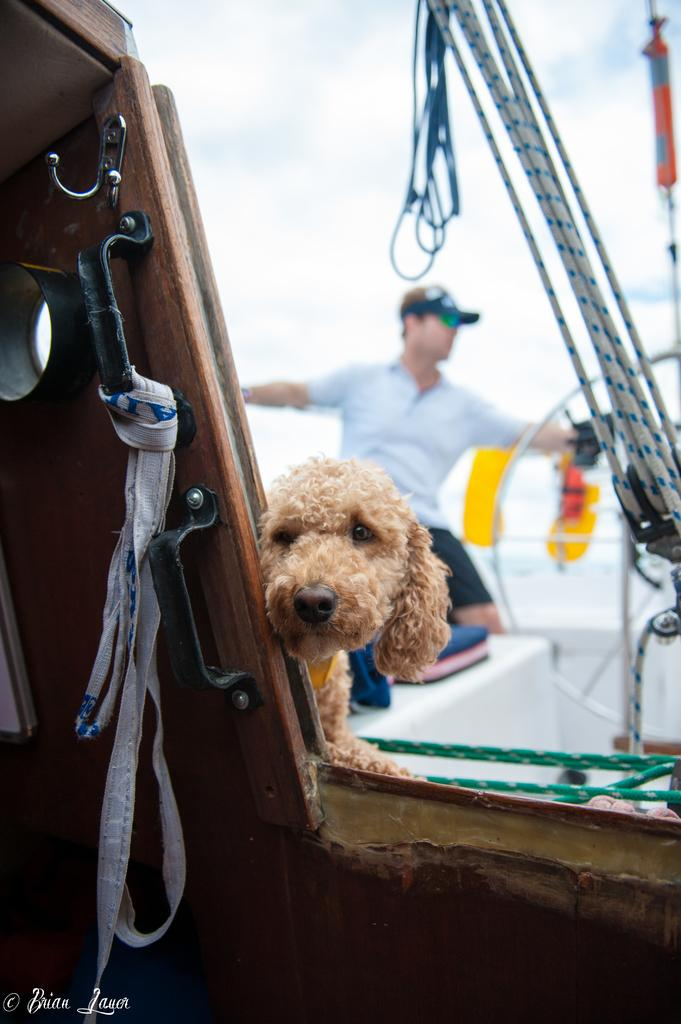What is the main subject in the foreground of the image? There is a dog in the foreground of the image. What is the dog positioned behind? The dog is behind a wooden object. What can be seen in the background of the image? There are ropes, a wheel, a man wearing a cap, and the sky visible in the background of the image. What is the condition of the sky in the image? The sky is visible in the background of the image, and there are clouds present. What time of day is depicted in the image, and what hour is it? The time of day cannot be determined from the image, and there is no hour mentioned. What type of soap is being used by the man in the image? There is no soap present in the image; the man is wearing a cap and standing near a wheel. 